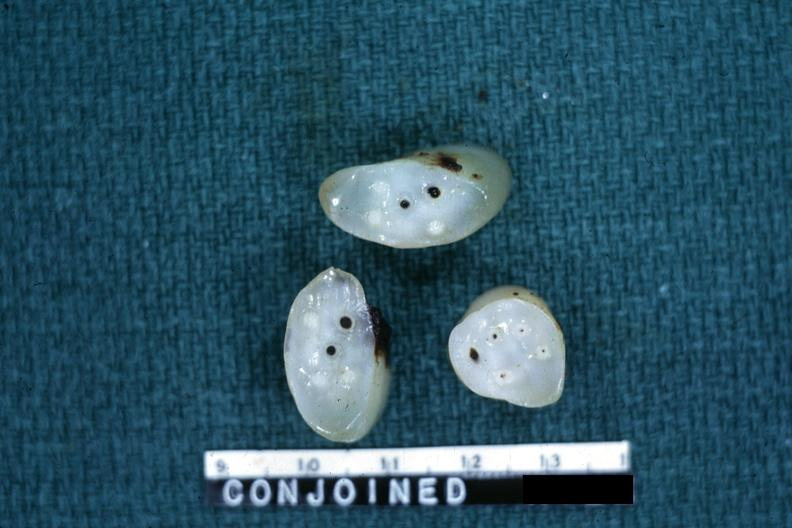does adenocarcinoma show cross sections showing apparently four arteries and two veins?
Answer the question using a single word or phrase. No 